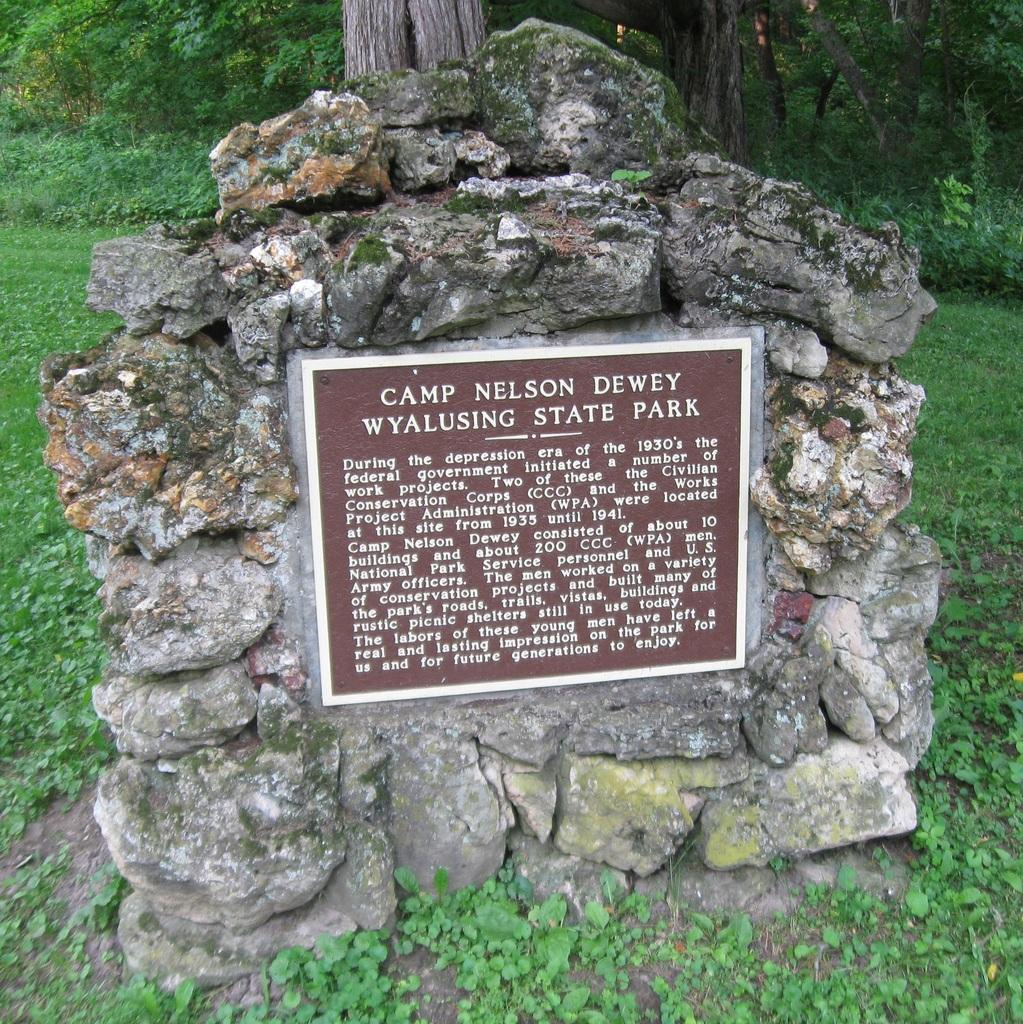What type of object is in the image? There is a stone object in the image. What can be seen on the stone object? Something is written on the stone object. What can be seen in the background of the image? There are trees and grass in the background of the image. What type of print can be seen on the stone object? There is no print visible on the stone object; it only has writing. Are there any fairies visible in the image? There are no fairies present in the image. 